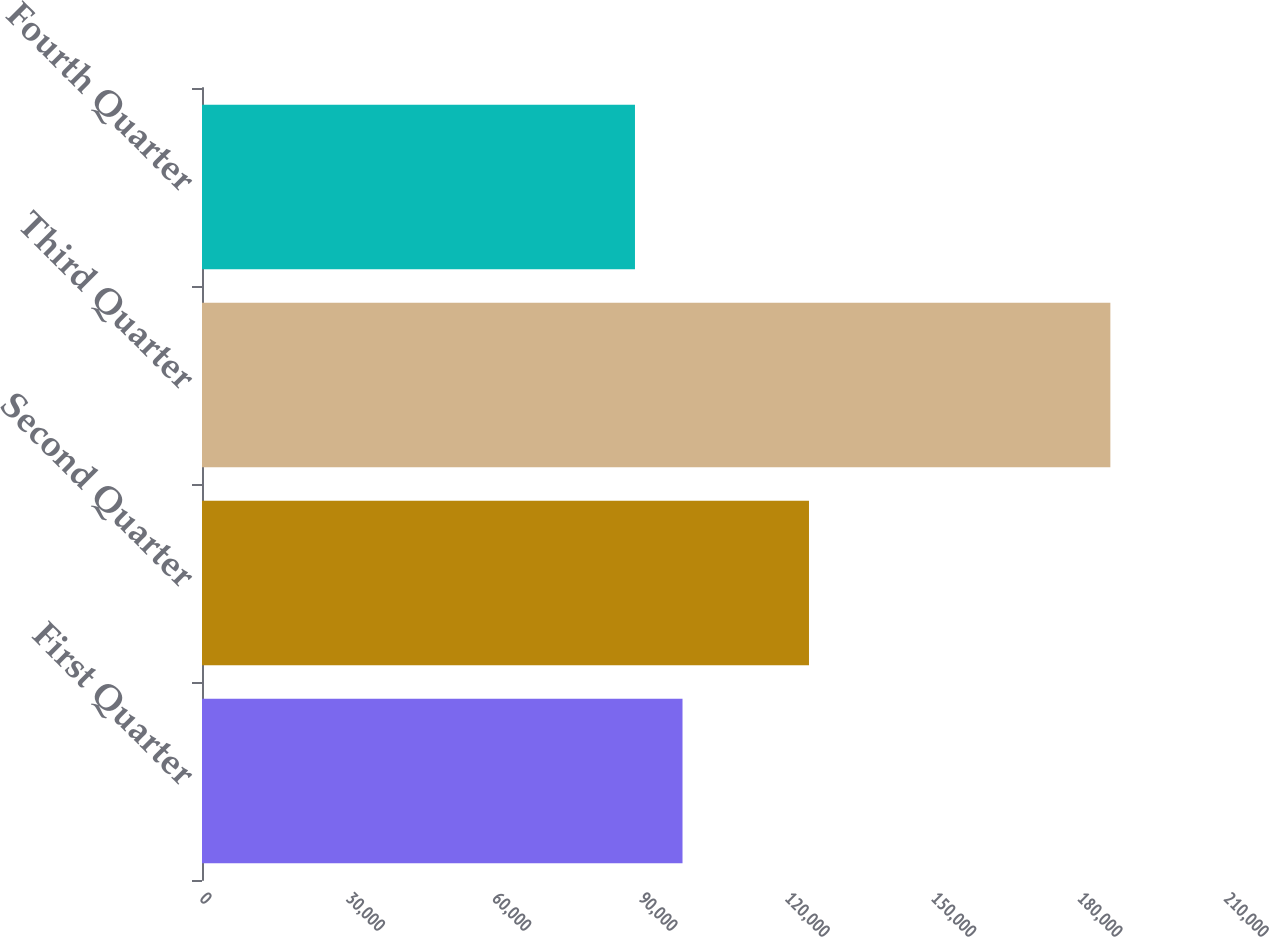<chart> <loc_0><loc_0><loc_500><loc_500><bar_chart><fcel>First Quarter<fcel>Second Quarter<fcel>Third Quarter<fcel>Fourth Quarter<nl><fcel>98543<fcel>124479<fcel>186284<fcel>88794<nl></chart> 